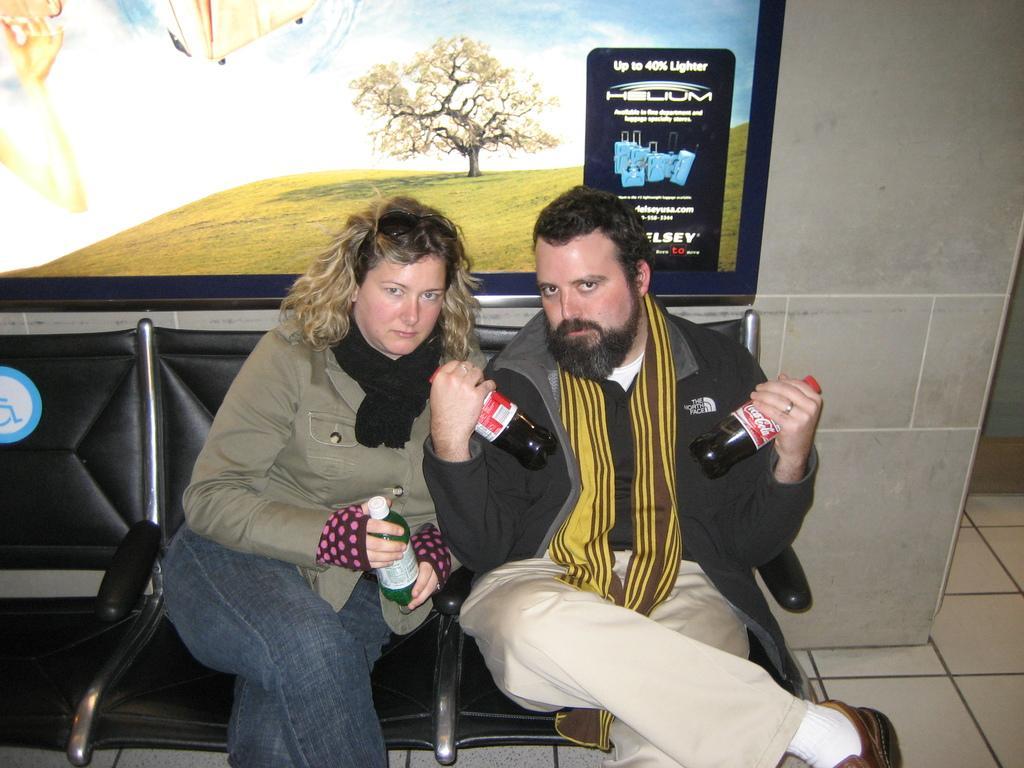How would you summarize this image in a sentence or two? In this image we can see a man and woman are sitting on a black color chair. Man is wearing black color coat with cream pant and holding coca cola bottle in his hands. Woman is wearing light brown color coat with jeans and holding bottle in her hand. Behind the wall is there and one poster is attached to the wall. 